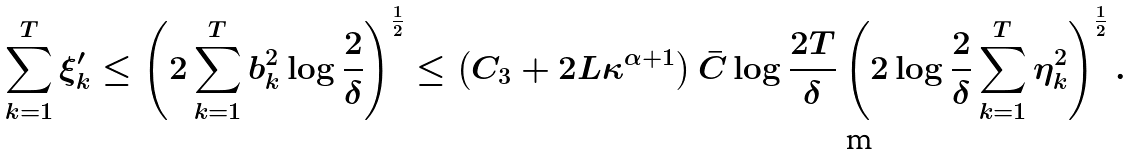<formula> <loc_0><loc_0><loc_500><loc_500>\sum _ { k = 1 } ^ { T } \xi _ { k } ^ { \prime } \leq \left ( 2 \sum _ { k = 1 } ^ { T } b _ { k } ^ { 2 } \log \frac { 2 } { \delta } \right ) ^ { \frac { 1 } { 2 } } \leq \left ( C _ { 3 } + 2 L \kappa ^ { \alpha + 1 } \right ) \bar { C } \log \frac { 2 T } { \delta } \left ( 2 \log \frac { 2 } { \delta } \sum _ { k = 1 } ^ { T } \eta _ { k } ^ { 2 } \right ) ^ { \frac { 1 } { 2 } } .</formula> 